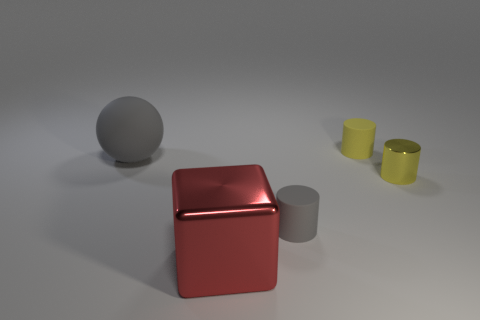Subtract all yellow cylinders. How many cylinders are left? 1 Subtract all gray cylinders. How many cylinders are left? 2 Add 4 yellow matte objects. How many objects exist? 9 Subtract all cylinders. How many objects are left? 2 Subtract all purple cylinders. Subtract all purple spheres. How many cylinders are left? 3 Subtract all cyan spheres. How many yellow cylinders are left? 2 Subtract all large gray rubber things. Subtract all tiny cylinders. How many objects are left? 1 Add 1 yellow rubber things. How many yellow rubber things are left? 2 Add 3 big red objects. How many big red objects exist? 4 Subtract 0 purple cylinders. How many objects are left? 5 